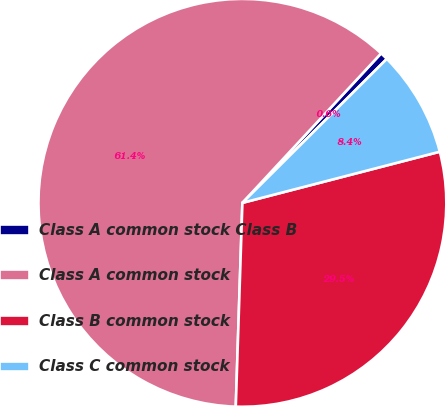Convert chart to OTSL. <chart><loc_0><loc_0><loc_500><loc_500><pie_chart><fcel>Class A common stock Class B<fcel>Class A common stock<fcel>Class B common stock<fcel>Class C common stock<nl><fcel>0.62%<fcel>61.39%<fcel>29.55%<fcel>8.44%<nl></chart> 